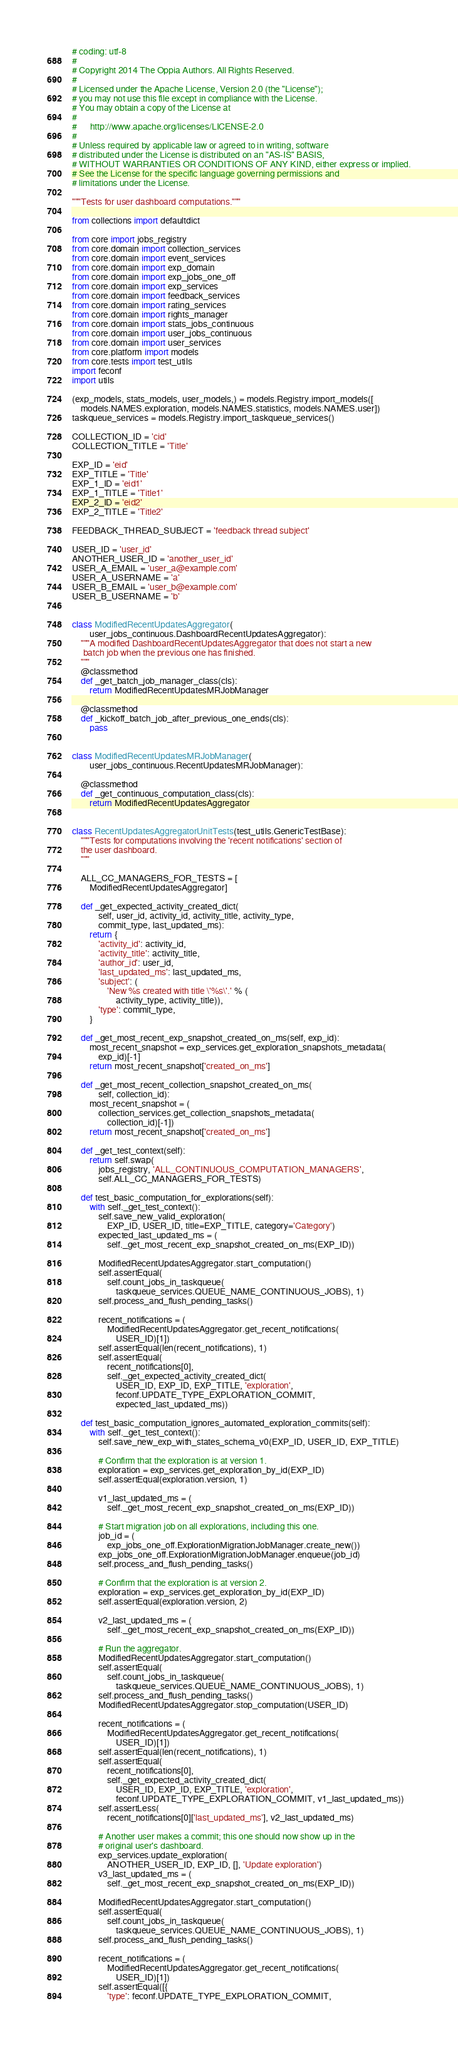Convert code to text. <code><loc_0><loc_0><loc_500><loc_500><_Python_># coding: utf-8
#
# Copyright 2014 The Oppia Authors. All Rights Reserved.
#
# Licensed under the Apache License, Version 2.0 (the "License");
# you may not use this file except in compliance with the License.
# You may obtain a copy of the License at
#
#      http://www.apache.org/licenses/LICENSE-2.0
#
# Unless required by applicable law or agreed to in writing, software
# distributed under the License is distributed on an "AS-IS" BASIS,
# WITHOUT WARRANTIES OR CONDITIONS OF ANY KIND, either express or implied.
# See the License for the specific language governing permissions and
# limitations under the License.

"""Tests for user dashboard computations."""

from collections import defaultdict

from core import jobs_registry
from core.domain import collection_services
from core.domain import event_services
from core.domain import exp_domain
from core.domain import exp_jobs_one_off
from core.domain import exp_services
from core.domain import feedback_services
from core.domain import rating_services
from core.domain import rights_manager
from core.domain import stats_jobs_continuous
from core.domain import user_jobs_continuous
from core.domain import user_services
from core.platform import models
from core.tests import test_utils
import feconf
import utils

(exp_models, stats_models, user_models,) = models.Registry.import_models([
    models.NAMES.exploration, models.NAMES.statistics, models.NAMES.user])
taskqueue_services = models.Registry.import_taskqueue_services()

COLLECTION_ID = 'cid'
COLLECTION_TITLE = 'Title'

EXP_ID = 'eid'
EXP_TITLE = 'Title'
EXP_1_ID = 'eid1'
EXP_1_TITLE = 'Title1'
EXP_2_ID = 'eid2'
EXP_2_TITLE = 'Title2'

FEEDBACK_THREAD_SUBJECT = 'feedback thread subject'

USER_ID = 'user_id'
ANOTHER_USER_ID = 'another_user_id'
USER_A_EMAIL = 'user_a@example.com'
USER_A_USERNAME = 'a'
USER_B_EMAIL = 'user_b@example.com'
USER_B_USERNAME = 'b'


class ModifiedRecentUpdatesAggregator(
        user_jobs_continuous.DashboardRecentUpdatesAggregator):
    """A modified DashboardRecentUpdatesAggregator that does not start a new
     batch job when the previous one has finished.
    """
    @classmethod
    def _get_batch_job_manager_class(cls):
        return ModifiedRecentUpdatesMRJobManager

    @classmethod
    def _kickoff_batch_job_after_previous_one_ends(cls):
        pass


class ModifiedRecentUpdatesMRJobManager(
        user_jobs_continuous.RecentUpdatesMRJobManager):

    @classmethod
    def _get_continuous_computation_class(cls):
        return ModifiedRecentUpdatesAggregator


class RecentUpdatesAggregatorUnitTests(test_utils.GenericTestBase):
    """Tests for computations involving the 'recent notifications' section of
    the user dashboard.
    """

    ALL_CC_MANAGERS_FOR_TESTS = [
        ModifiedRecentUpdatesAggregator]

    def _get_expected_activity_created_dict(
            self, user_id, activity_id, activity_title, activity_type,
            commit_type, last_updated_ms):
        return {
            'activity_id': activity_id,
            'activity_title': activity_title,
            'author_id': user_id,
            'last_updated_ms': last_updated_ms,
            'subject': (
                'New %s created with title \'%s\'.' % (
                    activity_type, activity_title)),
            'type': commit_type,
        }

    def _get_most_recent_exp_snapshot_created_on_ms(self, exp_id):
        most_recent_snapshot = exp_services.get_exploration_snapshots_metadata(
            exp_id)[-1]
        return most_recent_snapshot['created_on_ms']

    def _get_most_recent_collection_snapshot_created_on_ms(
            self, collection_id):
        most_recent_snapshot = (
            collection_services.get_collection_snapshots_metadata(
                collection_id)[-1])
        return most_recent_snapshot['created_on_ms']

    def _get_test_context(self):
        return self.swap(
            jobs_registry, 'ALL_CONTINUOUS_COMPUTATION_MANAGERS',
            self.ALL_CC_MANAGERS_FOR_TESTS)

    def test_basic_computation_for_explorations(self):
        with self._get_test_context():
            self.save_new_valid_exploration(
                EXP_ID, USER_ID, title=EXP_TITLE, category='Category')
            expected_last_updated_ms = (
                self._get_most_recent_exp_snapshot_created_on_ms(EXP_ID))

            ModifiedRecentUpdatesAggregator.start_computation()
            self.assertEqual(
                self.count_jobs_in_taskqueue(
                    taskqueue_services.QUEUE_NAME_CONTINUOUS_JOBS), 1)
            self.process_and_flush_pending_tasks()

            recent_notifications = (
                ModifiedRecentUpdatesAggregator.get_recent_notifications(
                    USER_ID)[1])
            self.assertEqual(len(recent_notifications), 1)
            self.assertEqual(
                recent_notifications[0],
                self._get_expected_activity_created_dict(
                    USER_ID, EXP_ID, EXP_TITLE, 'exploration',
                    feconf.UPDATE_TYPE_EXPLORATION_COMMIT,
                    expected_last_updated_ms))

    def test_basic_computation_ignores_automated_exploration_commits(self):
        with self._get_test_context():
            self.save_new_exp_with_states_schema_v0(EXP_ID, USER_ID, EXP_TITLE)

            # Confirm that the exploration is at version 1.
            exploration = exp_services.get_exploration_by_id(EXP_ID)
            self.assertEqual(exploration.version, 1)

            v1_last_updated_ms = (
                self._get_most_recent_exp_snapshot_created_on_ms(EXP_ID))

            # Start migration job on all explorations, including this one.
            job_id = (
                exp_jobs_one_off.ExplorationMigrationJobManager.create_new())
            exp_jobs_one_off.ExplorationMigrationJobManager.enqueue(job_id)
            self.process_and_flush_pending_tasks()

            # Confirm that the exploration is at version 2.
            exploration = exp_services.get_exploration_by_id(EXP_ID)
            self.assertEqual(exploration.version, 2)

            v2_last_updated_ms = (
                self._get_most_recent_exp_snapshot_created_on_ms(EXP_ID))

            # Run the aggregator.
            ModifiedRecentUpdatesAggregator.start_computation()
            self.assertEqual(
                self.count_jobs_in_taskqueue(
                    taskqueue_services.QUEUE_NAME_CONTINUOUS_JOBS), 1)
            self.process_and_flush_pending_tasks()
            ModifiedRecentUpdatesAggregator.stop_computation(USER_ID)

            recent_notifications = (
                ModifiedRecentUpdatesAggregator.get_recent_notifications(
                    USER_ID)[1])
            self.assertEqual(len(recent_notifications), 1)
            self.assertEqual(
                recent_notifications[0],
                self._get_expected_activity_created_dict(
                    USER_ID, EXP_ID, EXP_TITLE, 'exploration',
                    feconf.UPDATE_TYPE_EXPLORATION_COMMIT, v1_last_updated_ms))
            self.assertLess(
                recent_notifications[0]['last_updated_ms'], v2_last_updated_ms)

            # Another user makes a commit; this one should now show up in the
            # original user's dashboard.
            exp_services.update_exploration(
                ANOTHER_USER_ID, EXP_ID, [], 'Update exploration')
            v3_last_updated_ms = (
                self._get_most_recent_exp_snapshot_created_on_ms(EXP_ID))

            ModifiedRecentUpdatesAggregator.start_computation()
            self.assertEqual(
                self.count_jobs_in_taskqueue(
                    taskqueue_services.QUEUE_NAME_CONTINUOUS_JOBS), 1)
            self.process_and_flush_pending_tasks()

            recent_notifications = (
                ModifiedRecentUpdatesAggregator.get_recent_notifications(
                    USER_ID)[1])
            self.assertEqual([{
                'type': feconf.UPDATE_TYPE_EXPLORATION_COMMIT,</code> 